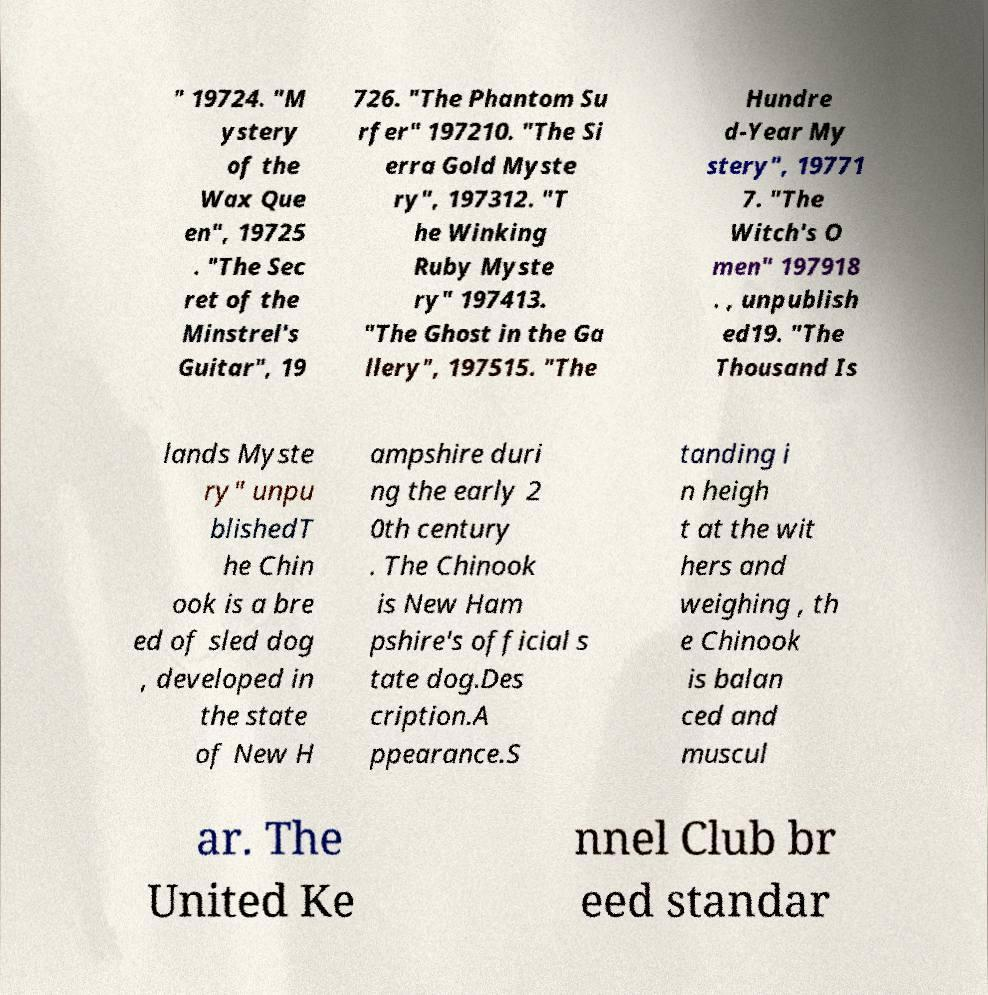What messages or text are displayed in this image? I need them in a readable, typed format. " 19724. "M ystery of the Wax Que en", 19725 . "The Sec ret of the Minstrel's Guitar", 19 726. "The Phantom Su rfer" 197210. "The Si erra Gold Myste ry", 197312. "T he Winking Ruby Myste ry" 197413. "The Ghost in the Ga llery", 197515. "The Hundre d-Year My stery", 19771 7. "The Witch's O men" 197918 . , unpublish ed19. "The Thousand Is lands Myste ry" unpu blishedT he Chin ook is a bre ed of sled dog , developed in the state of New H ampshire duri ng the early 2 0th century . The Chinook is New Ham pshire's official s tate dog.Des cription.A ppearance.S tanding i n heigh t at the wit hers and weighing , th e Chinook is balan ced and muscul ar. The United Ke nnel Club br eed standar 